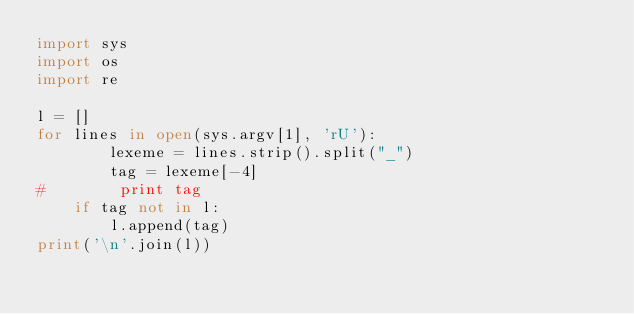<code> <loc_0><loc_0><loc_500><loc_500><_Python_>import sys
import os
import re

l = []
for lines in open(sys.argv[1], 'rU'):
        lexeme = lines.strip().split("_")
        tag = lexeme[-4]
#        print tag 
	if tag not in l:
		l.append(tag)
print('\n'.join(l))

</code> 